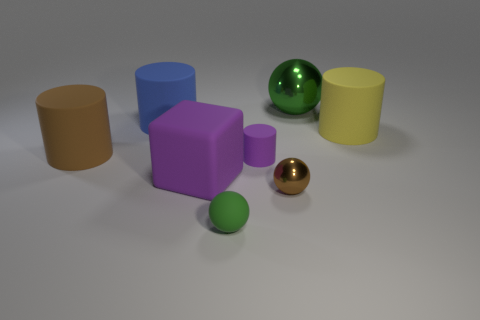What is the color of the other metal object that is the same shape as the tiny brown shiny object?
Keep it short and to the point. Green. Do the purple matte thing that is behind the big purple cube and the green sphere behind the big brown matte thing have the same size?
Provide a succinct answer. No. Do the large brown rubber thing and the large blue thing have the same shape?
Provide a succinct answer. Yes. How many objects are green balls that are behind the big purple matte cube or small matte objects?
Give a very brief answer. 3. Is there a tiny rubber thing of the same shape as the big green metallic object?
Your response must be concise. Yes. Are there the same number of yellow rubber cylinders that are behind the blue rubber cylinder and brown spheres?
Your response must be concise. No. What shape is the thing that is the same color as the tiny rubber sphere?
Offer a very short reply. Sphere. How many matte blocks have the same size as the yellow matte object?
Provide a short and direct response. 1. How many small matte cylinders are on the left side of the matte block?
Provide a succinct answer. 0. What material is the green ball behind the brown object that is to the left of the large blue matte thing made of?
Your answer should be compact. Metal. 